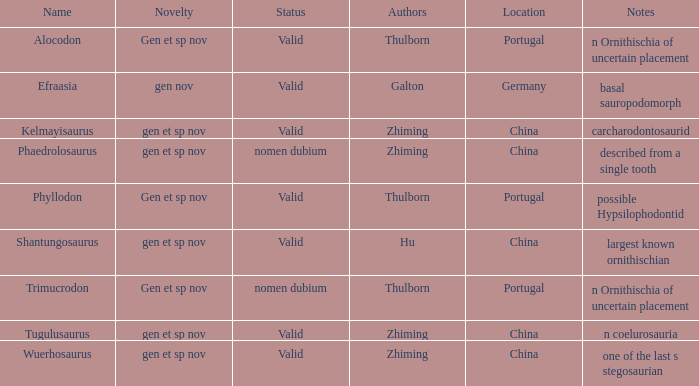What is the Status of the dinosaur, whose notes are, "n coelurosauria"? Valid. 